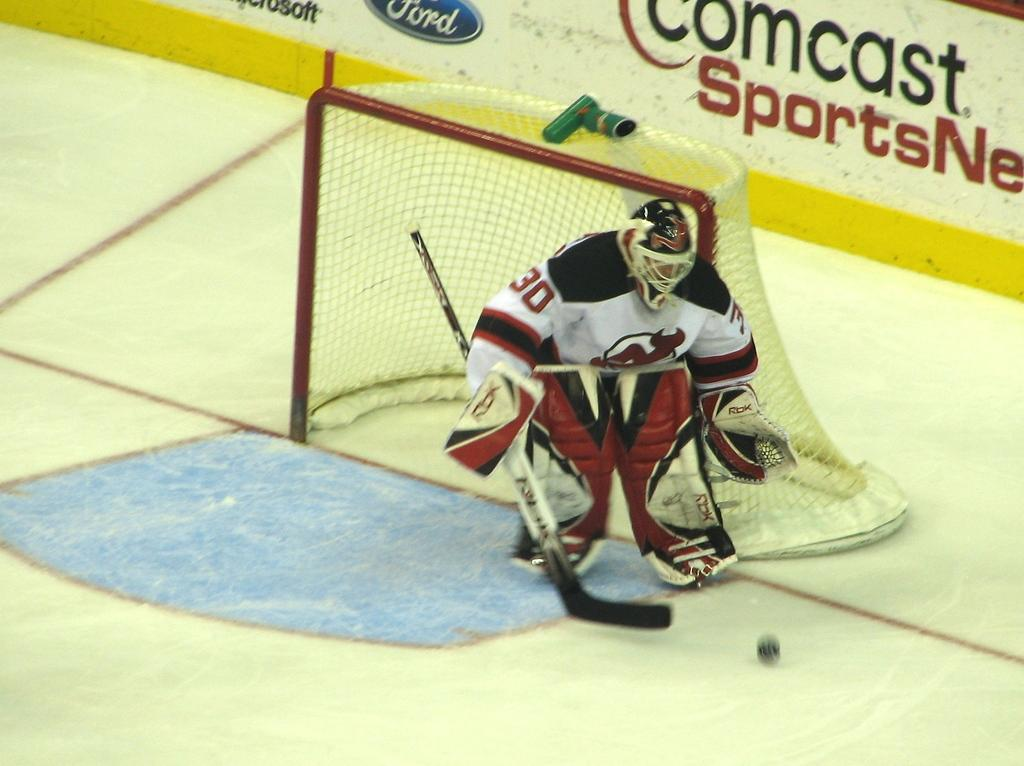What is the person in the image doing? The person is skiing on the floor. What object is the person holding while skiing? The person is holding a bat. What can be seen in the background of the image? There is a net and a wall in the background of the image. How much profit did the person make from the story in the image? There is no story or mention of profit in the image; it features a person skiing on the floor while holding a bat. 